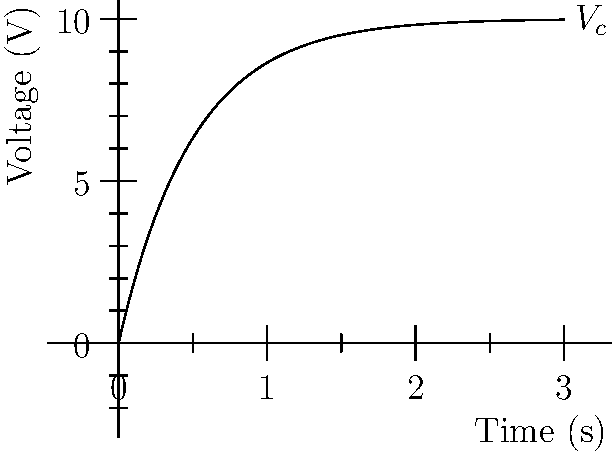At the funeral, you overhear two electrical engineers discussing a capacitor charging circuit. They show you this voltage vs. time graph for a charging capacitor in an RC circuit. If the time constant (τ) of the circuit is 0.5 seconds, what is the final steady-state voltage of the capacitor? To find the final steady-state voltage of the capacitor, we need to analyze the graph and use our knowledge of RC circuits. Let's break it down step-by-step:

1. In an RC charging circuit, the voltage across the capacitor follows the equation:
   $V_c(t) = V_f(1 - e^{-t/\tau})$
   where $V_f$ is the final steady-state voltage, $t$ is time, and $\tau$ is the time constant.

2. We're given that the time constant $\tau = 0.5$ seconds.

3. Looking at the graph, we can see that the voltage asymptotically approaches a final value.

4. To determine this final value, we need to look at the y-axis scale. The voltage appears to be approaching 10 volts.

5. We can verify this by checking a point on the curve. At $t = 3$ seconds (which is 6 time constants):
   $V_c(3) = 10(1 - e^{-3/0.5}) \approx 9.95$ volts

6. This confirms that the final steady-state voltage is indeed 10 volts.

Therefore, the final steady-state voltage of the capacitor is 10 volts.
Answer: 10 volts 